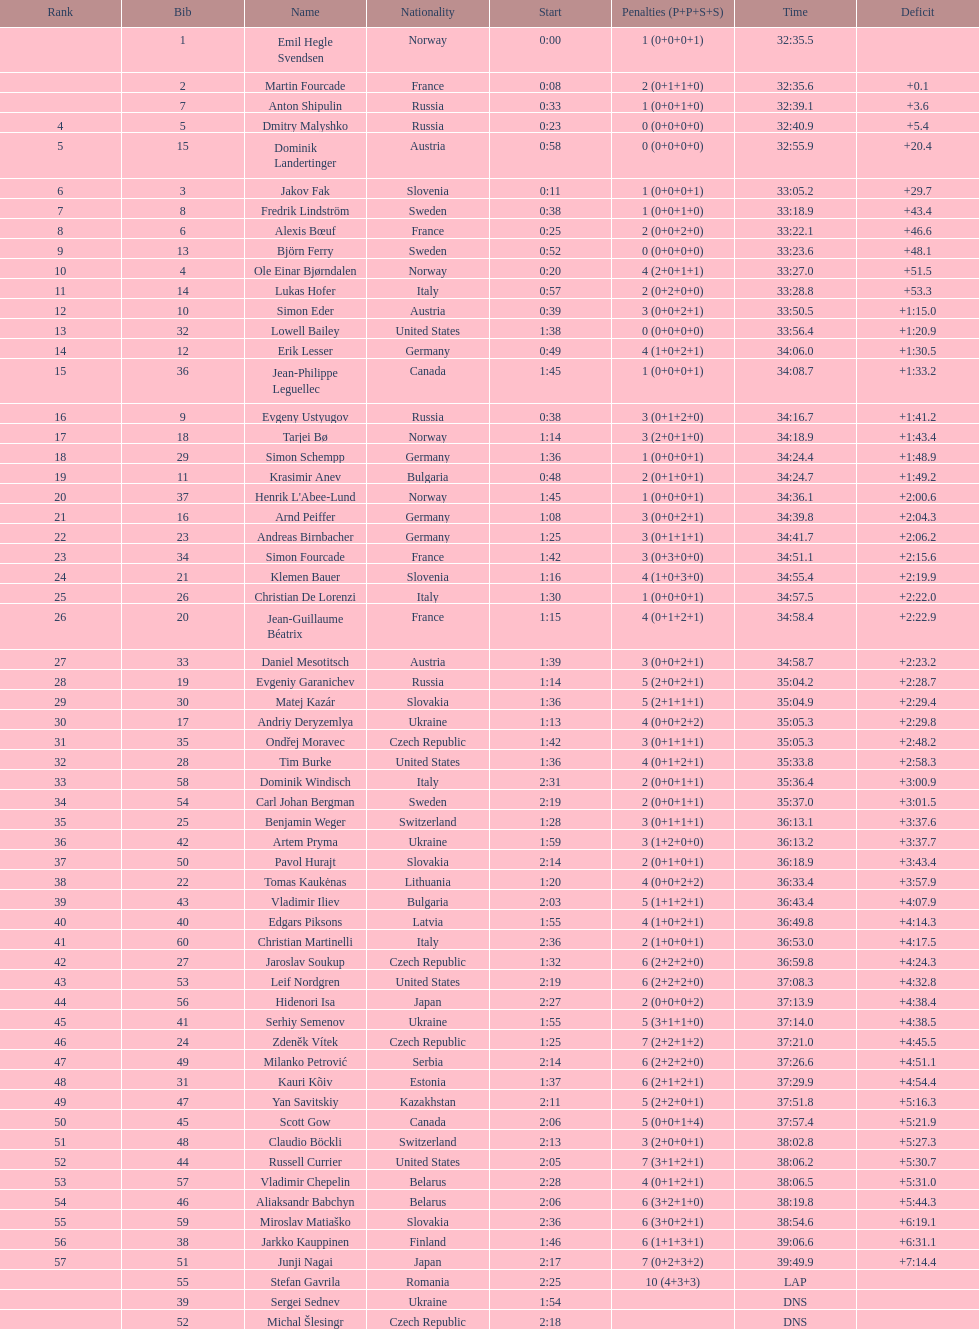What is the largest sanction? 10. 